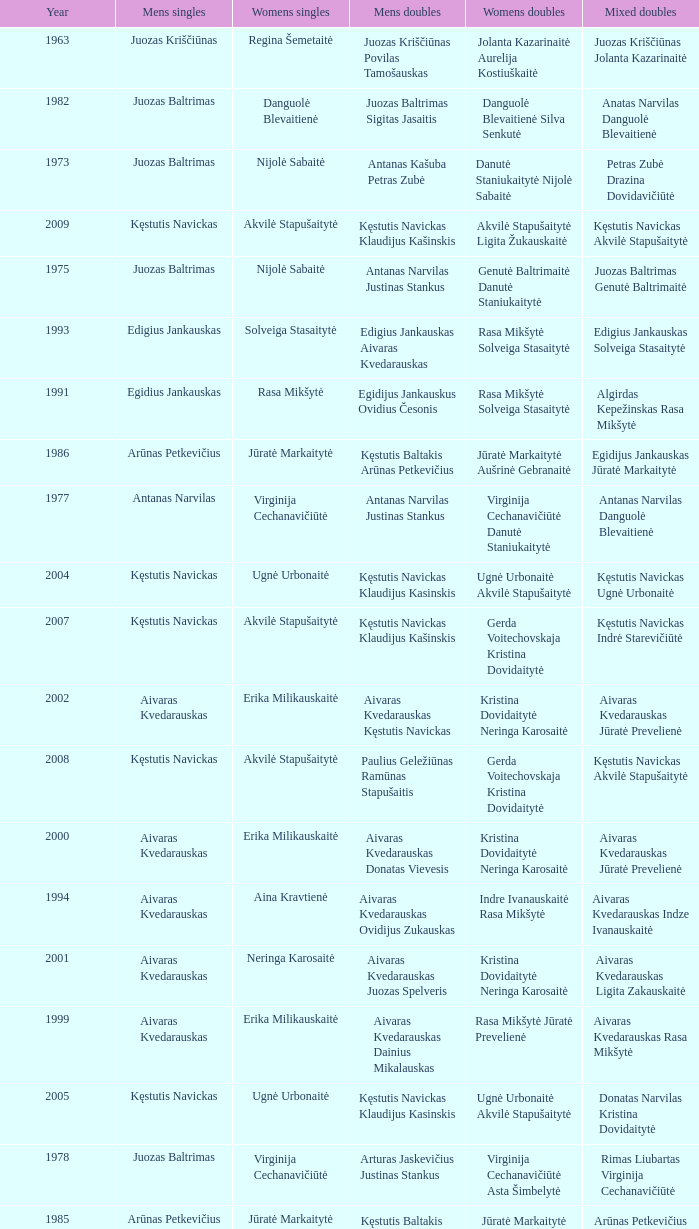What was the first year of the Lithuanian National Badminton Championships? 1963.0. 